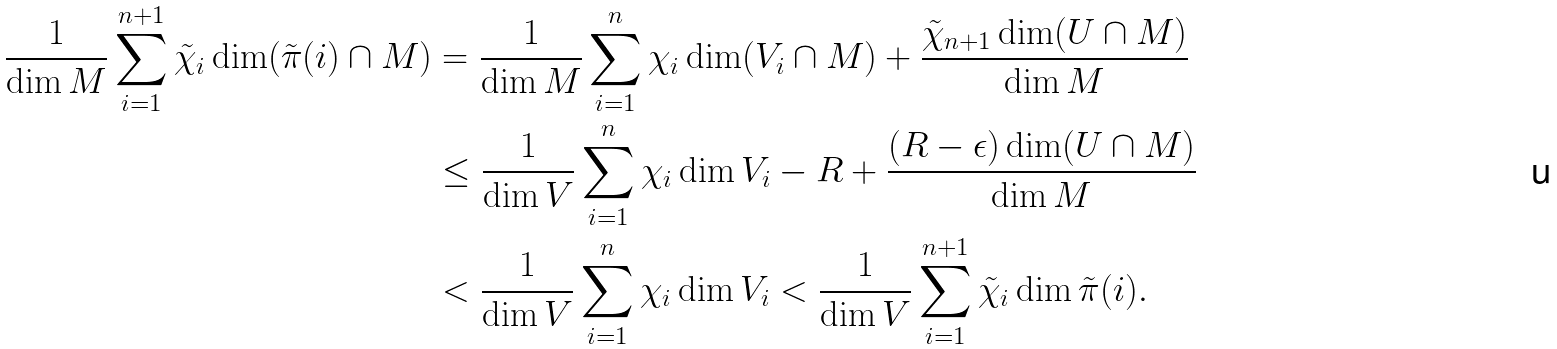<formula> <loc_0><loc_0><loc_500><loc_500>\frac { 1 } { \dim M } \sum _ { i = 1 } ^ { n + 1 } \tilde { \chi } _ { i } \dim ( \tilde { \pi } ( i ) \cap M ) & = \frac { 1 } { \dim M } \sum _ { i = 1 } ^ { n } \chi _ { i } \dim ( V _ { i } \cap M ) + \frac { \tilde { \chi } _ { n + 1 } \dim ( U \cap M ) } { \dim M } \\ & \leq \frac { 1 } { \dim V } \sum _ { i = 1 } ^ { n } \chi _ { i } \dim V _ { i } - R + \frac { ( R - \epsilon ) \dim ( U \cap M ) } { \dim M } \\ & < \frac { 1 } { \dim V } \sum _ { i = 1 } ^ { n } \chi _ { i } \dim V _ { i } < \frac { 1 } { \dim V } \sum _ { i = 1 } ^ { n + 1 } \tilde { \chi } _ { i } \dim \tilde { \pi } ( i ) .</formula> 